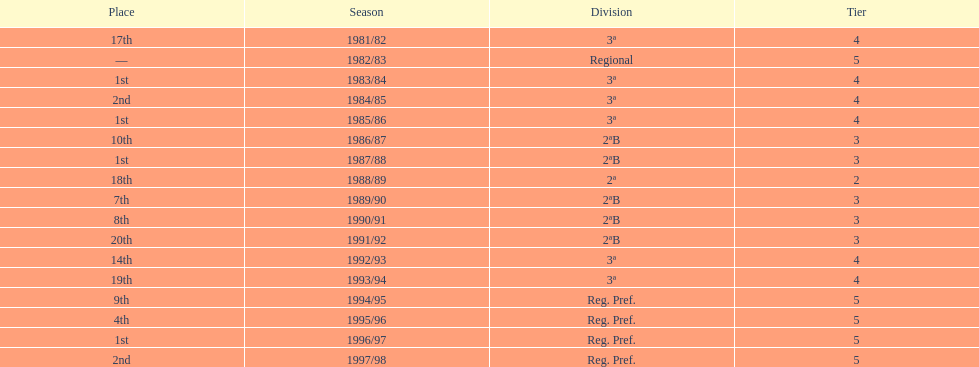Which tier was ud alzira a part of the least? 2. 